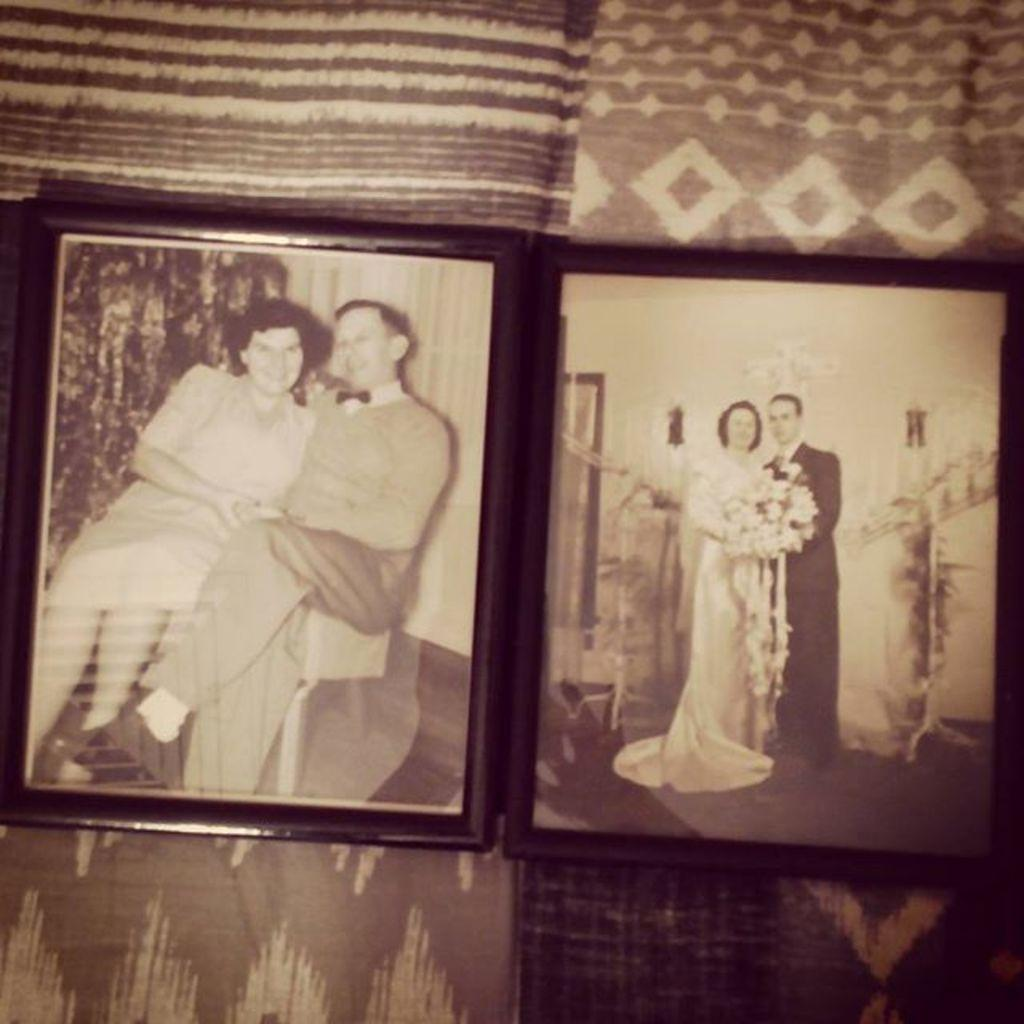What objects are present in the image that are typically used for displaying photos? There are photo frames in the image. What type of floor covering is visible in the image? There are mats in the image. What type of stew is being prepared in the image? There is no stew present in the image; it features photo frames and mats. What holiday is being celebrated in the image? There is no indication of a holiday being celebrated in the image. 